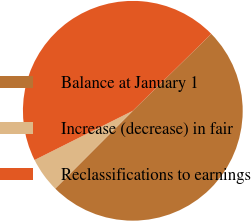Convert chart to OTSL. <chart><loc_0><loc_0><loc_500><loc_500><pie_chart><fcel>Balance at January 1<fcel>Increase (decrease) in fair<fcel>Reclassifications to earnings<nl><fcel>49.82%<fcel>5.13%<fcel>45.05%<nl></chart> 